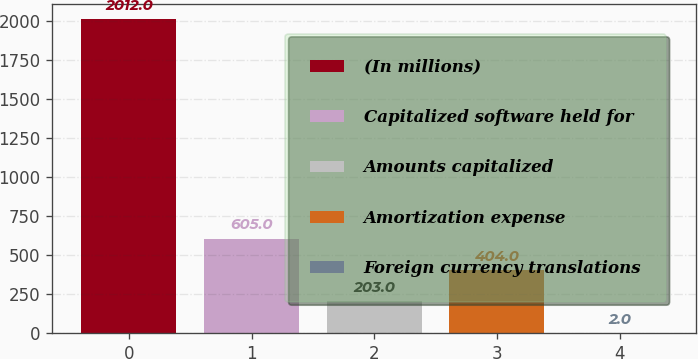<chart> <loc_0><loc_0><loc_500><loc_500><bar_chart><fcel>(In millions)<fcel>Capitalized software held for<fcel>Amounts capitalized<fcel>Amortization expense<fcel>Foreign currency translations<nl><fcel>2012<fcel>605<fcel>203<fcel>404<fcel>2<nl></chart> 